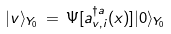<formula> <loc_0><loc_0><loc_500><loc_500>| v \rangle _ { Y _ { 0 } } \, = \, \Psi [ a ^ { \dagger a } _ { v , i } ( x ) ] | 0 \rangle _ { Y _ { 0 } }</formula> 